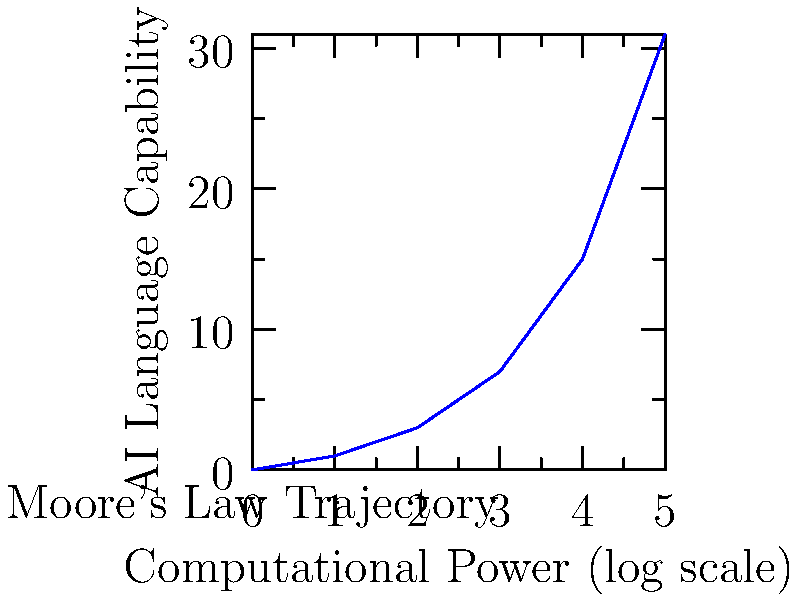Analyze the graph depicting the relationship between computational power and AI language capabilities. How does this trend align with the concept of exponential growth in AI development, and what implications might this have for creating scientifically accurate AI characters in future novels? 1. Observe the graph: The x-axis represents computational power on a logarithmic scale, while the y-axis shows AI language capability.

2. Identify the curve: The line is not straight but curves upward, indicating a non-linear relationship.

3. Recognize exponential growth: The curve's shape suggests exponential growth, where AI language capabilities increase at a faster rate as computational power increases.

4. Relate to Moore's Law: This trend aligns with Moore's Law, which predicts exponential growth in computing power over time.

5. AI development implications: As computational power increases, AI language capabilities are likely to improve at an accelerating rate.

6. Scientific accuracy in AI characters: This trend suggests that future AI characters in novels should demonstrate rapidly increasing linguistic sophistication and cognitive abilities over relatively short time spans.

7. Potential narrative challenges: Authors may need to consider how quickly AI characters could evolve within a story's timeline, potentially surpassing human-level language abilities.

8. Ethical and societal implications: The graph implies potential rapid developments in AI, which could lead to complex ethical scenarios and societal changes that could be explored in novels.

9. Limitations and uncertainties: While the trend is clear, it's important to consider potential plateaus or unforeseen obstacles in AI development that could affect the trajectory.

10. Interdisciplinary approach: Creating scientifically accurate AI characters may require integrating knowledge from computer science, linguistics, and cognitive science to reflect this exponential growth trend realistically.
Answer: Exponential growth in AI language capabilities, implying rapid evolution of AI characters' sophistication in future novels. 